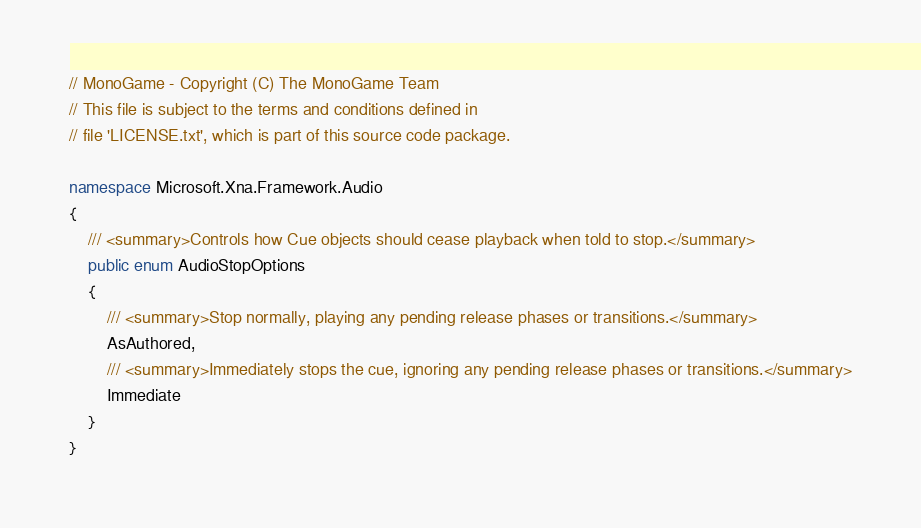<code> <loc_0><loc_0><loc_500><loc_500><_C#_>// MonoGame - Copyright (C) The MonoGame Team
// This file is subject to the terms and conditions defined in
// file 'LICENSE.txt', which is part of this source code package.

namespace Microsoft.Xna.Framework.Audio
{
    /// <summary>Controls how Cue objects should cease playback when told to stop.</summary>
	public enum AudioStopOptions
    {
        /// <summary>Stop normally, playing any pending release phases or transitions.</summary>
		AsAuthored,
        /// <summary>Immediately stops the cue, ignoring any pending release phases or transitions.</summary>
		Immediate
    }
}

</code> 